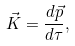Convert formula to latex. <formula><loc_0><loc_0><loc_500><loc_500>\vec { K } = \frac { d \vec { p } } { d \tau } ,</formula> 